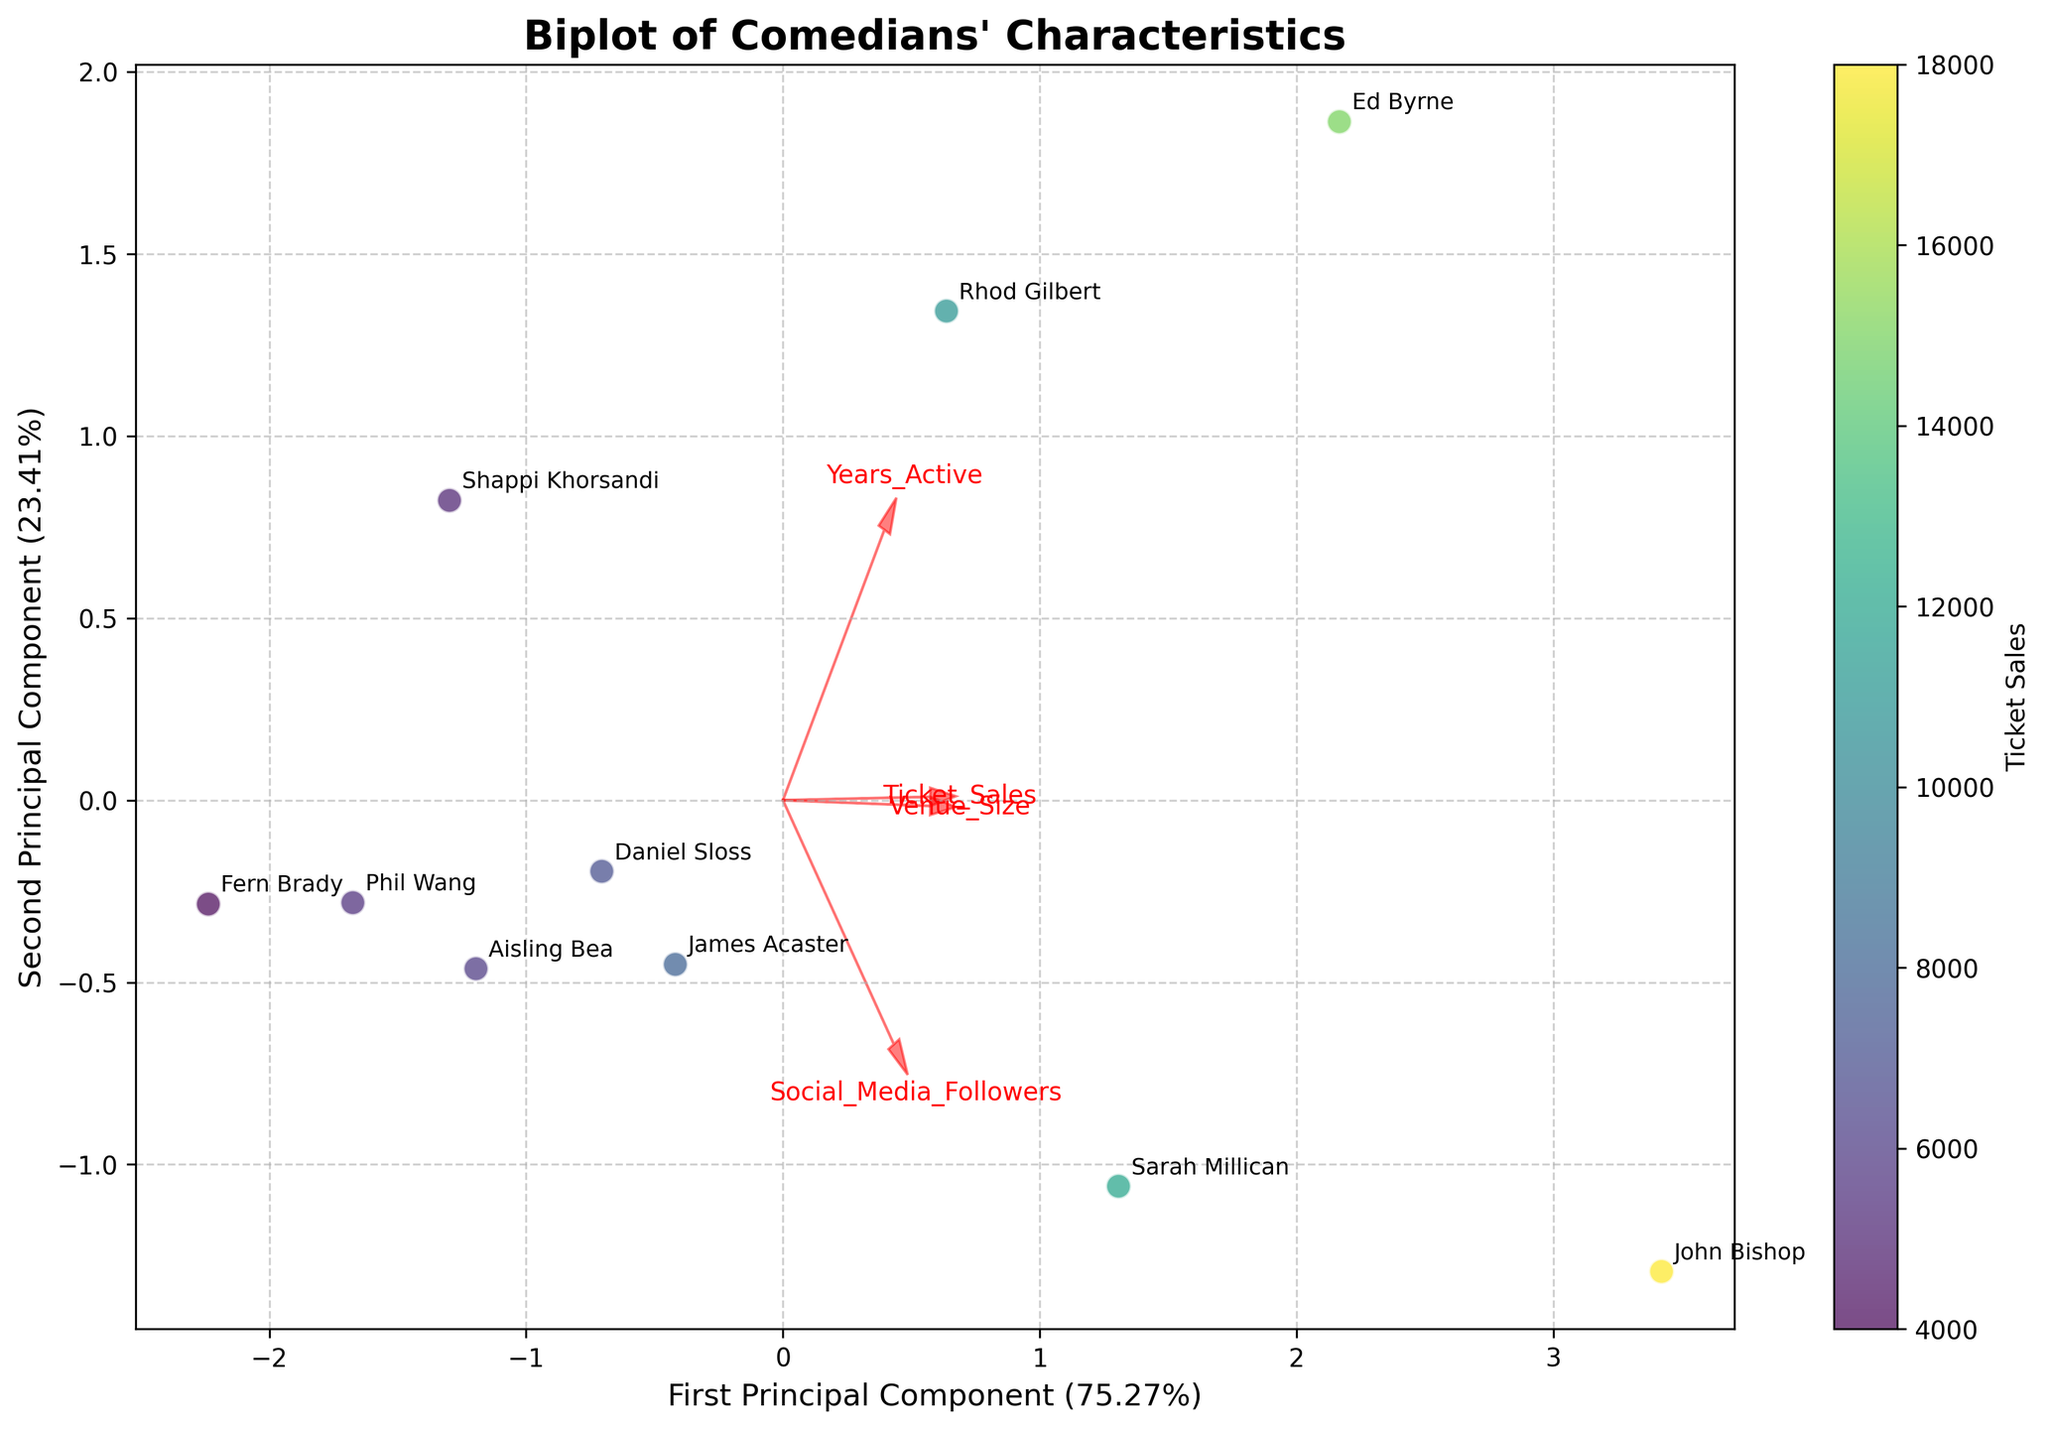What’s the title of the plot? The title of the plot is often located at the top center of the figure. Here, "Biplot of Comedians’ Characteristics" is clearly stated.
Answer: Biplot of Comedians’ Characteristics How many principal components are displayed on the plot? The x-axis and y-axis labels indicate the components, showing "First Principal Component" and "Second Principal Component". So, there are two principal components displayed.
Answer: Two Which comedian has the highest ticket sales? The color legend represents ticket sales, and the brightest data point represents the highest ticket sales. By referring to the annotated names, it's John Bishop with a value of 18,000.
Answer: John Bishop Which feature vector has the largest horizontal component? By observing the arrows and their lengths on the plot, the "Social_Media_Followers" vector extends the farthest horizontally (left to right).
Answer: Social_Media_Followers Which comedians have more years active than Sarah Millican? Sarah Millican is marked on the plot, and comedians placed to the right of the "Years_Active" vector likely have more years active. From the annotations, Ed Byrne, Rhod Gilbert, and Shappi Khorsandi fulfill this criterion.
Answer: Ed Byrne, Rhod Gilbert, Shappi Khorsandi Does Ed Byrne have more or less social media followers than Sarah Millican? By observing the direction of the "Social_Media_Followers" vector and the position of Ed Byrne and Sarah Millican on the plot concerning this vector, Sarah Millican is farther along this vector, indicating more followers.
Answer: Less Identify the feature that differentiates James Acaster and Daniel Sloss the most. James Acaster and Daniel Sloss appear close, but the "Years_Active" vector reveals that Daniel Sloss is slightly more aligned with this vector. The "Social_Media_Followers" vector also shows some differentiation. "Years_Active" seems to be the most distinguishing.
Answer: Years_Active What percentage of the variance is explained by the first principal component? The x-axis label provides the percentage explained by the first principal component, typically marked in parentheses.
Answer: Approximately 54% How are Ticket_Sales and Venue_Size related as seen in the plot? The respective vectors for "Ticket_Sales" and "Venue_Size" point in almost the same direction, indicating a high degree of positive correlation between these two features.
Answer: Positively correlated Which feature is least correlated with Venue_Size? Examining the angles formed by the vectors, "Years_Active" forms the largest angle with "Venue_Size", suggesting the least correlation.
Answer: Years_Active 